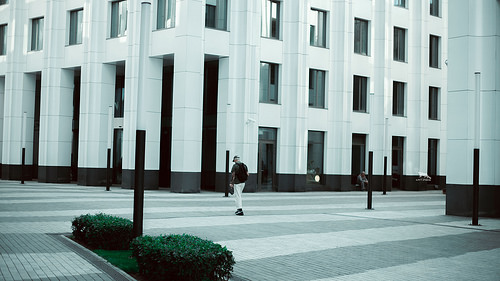<image>
Can you confirm if the building is in front of the man? Yes. The building is positioned in front of the man, appearing closer to the camera viewpoint. 